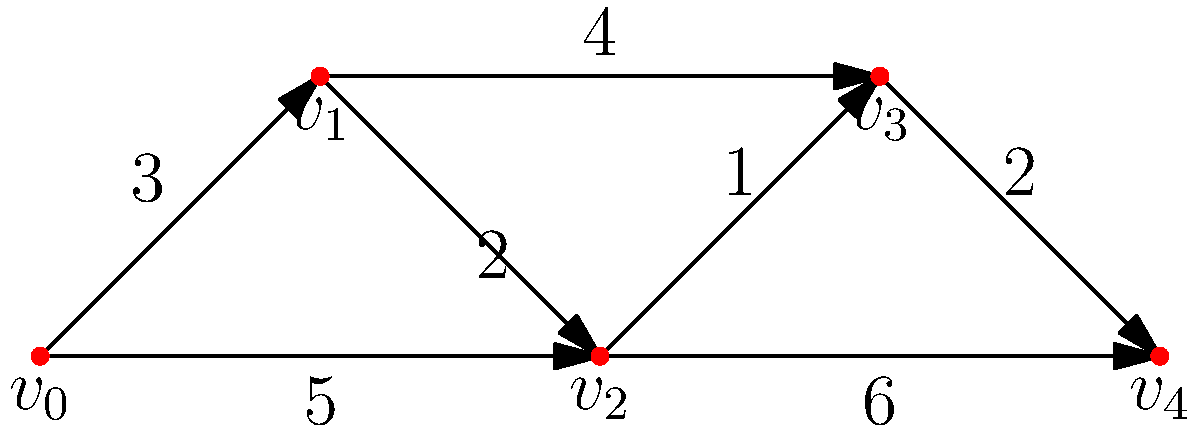As a diplomat involved in negotiations between Iran and the U.S., you need to visit multiple negotiation points represented by vertices $v_0$ to $v_4$ in the graph. The edges represent travel routes with associated costs (in days). Starting from $v_0$, what is the minimum total cost to visit all negotiation points and end at $v_4$, visiting each point exactly once? To solve this problem, we need to find the shortest Hamiltonian path from $v_0$ to $v_4$. Let's examine all possible paths:

1. $v_0 \rightarrow v_1 \rightarrow v_2 \rightarrow v_3 \rightarrow v_4$:
   Cost = 3 + 2 + 1 + 2 = 8 days

2. $v_0 \rightarrow v_1 \rightarrow v_3 \rightarrow v_2 \rightarrow v_4$:
   Cost = 3 + 4 + 1 + 6 = 14 days

3. $v_0 \rightarrow v_2 \rightarrow v_1 \rightarrow v_3 \rightarrow v_4$:
   Cost = 5 + 2 + 4 + 2 = 13 days

4. $v_0 \rightarrow v_2 \rightarrow v_3 \rightarrow v_1 \rightarrow v_4$:
   This path is invalid as it doesn't end at $v_4$

5. $v_0 \rightarrow v_2 \rightarrow v_3 \rightarrow v_4$:
   Cost = 5 + 1 + 2 = 8 days

The minimum cost path is either path 1 or path 5, both with a total cost of 8 days.
Answer: 8 days 